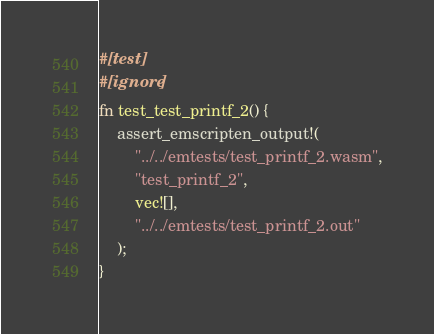<code> <loc_0><loc_0><loc_500><loc_500><_Rust_>#[test]
#[ignore]
fn test_test_printf_2() {
    assert_emscripten_output!(
        "../../emtests/test_printf_2.wasm",
        "test_printf_2",
        vec![],
        "../../emtests/test_printf_2.out"
    );
}
</code> 